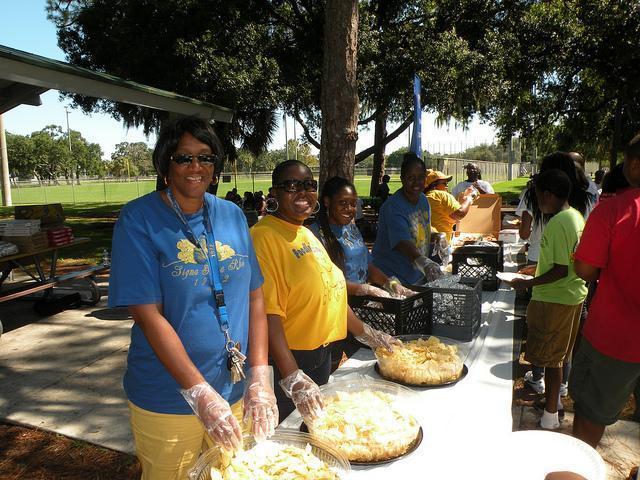How many people are wearing sunglasses?
Give a very brief answer. 2. How many bowls are there?
Give a very brief answer. 3. How many people are there?
Give a very brief answer. 7. How many bananas are there?
Give a very brief answer. 0. 